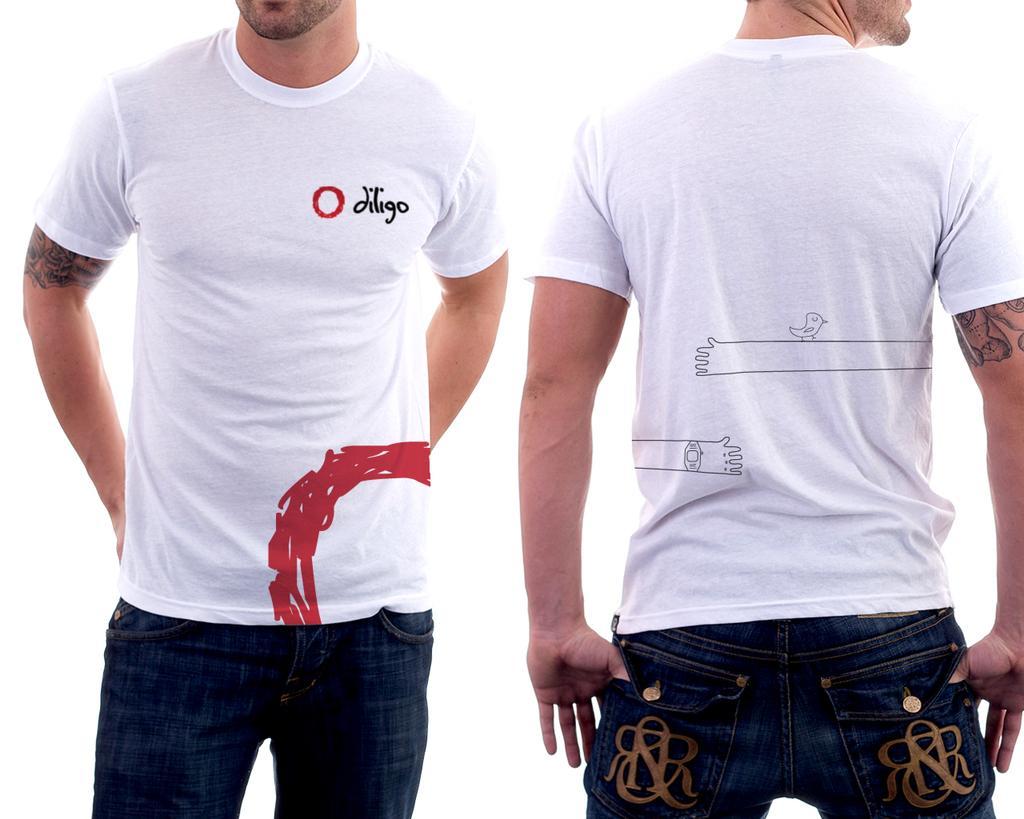Can you describe this image briefly? In this picture we can see two people with tattoos on them and in the background we can see it is white color. 